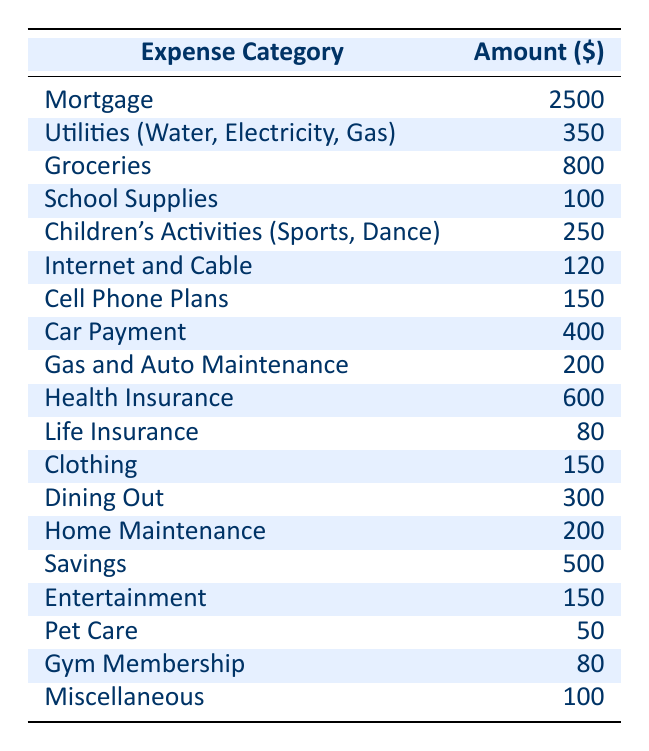What is the total amount spent on groceries and dining out? The amount spent on groceries is $800 and the amount spent on dining out is $300. Adding these two amounts gives: 800 + 300 = 1100.
Answer: 1100 What percentage of the total budget is allocated to health insurance? First, we need to find the total budget by summing all individual expenses: 2500 + 350 + 800 + 100 + 250 + 120 + 150 + 400 + 200 + 600 + 80 + 150 + 300 + 200 + 500 + 150 + 50 + 80 + 100 = 7220. The amount for health insurance is $600. Now, we calculate the percentage: (600 / 7220) * 100 ≈ 8.31%.
Answer: 8.31% Is the amount spent on children's activities greater than that spent on clothing? The amount for children's activities is $250, and the amount for clothing is $150. Comparing the two amounts, we can see that 250 is greater than 150, so the statement is true.
Answer: Yes What is the total amount allocated for savings, entertainment, and gym membership? The amount for savings is $500, entertainment is $150, and gym membership is $80. Adding these amounts gives: 500 + 150 + 80 = 730.
Answer: 730 Which expense category has the lowest expenditure? By reviewing the table, we can see that Pet Care has an amount of $50, which is lower than any other category in the table.
Answer: Pet Care What is the average amount spent on insurance (both health and life insurance)? The amount for health insurance is $600, and for life insurance, it is $80. To find the average, first sum these amounts: 600 + 80 = 680. Then divide by the number of insurance categories: 680 / 2 = 340.
Answer: 340 How much more is spent on utilities compared to school supplies? The amount for utilities is $350, and for school supplies, it's $100. To find the difference, subtract the amount for school supplies from that of utilities: 350 - 100 = 250.
Answer: 250 Is the total for car payment and gas and auto maintenance less than $700? The car payment is $400 and gas and auto maintenance is $200. Adding these gives us 400 + 200 = 600, which is less than $700, so the statement is true.
Answer: Yes What is the sum of the amounts for internet and cable, cell phone plans, and dining out? The amount for internet and cable is $120, for cell phone plans is $150, and dining out is $300. Adding these amounts gives: 120 + 150 + 300 = 570.
Answer: 570 